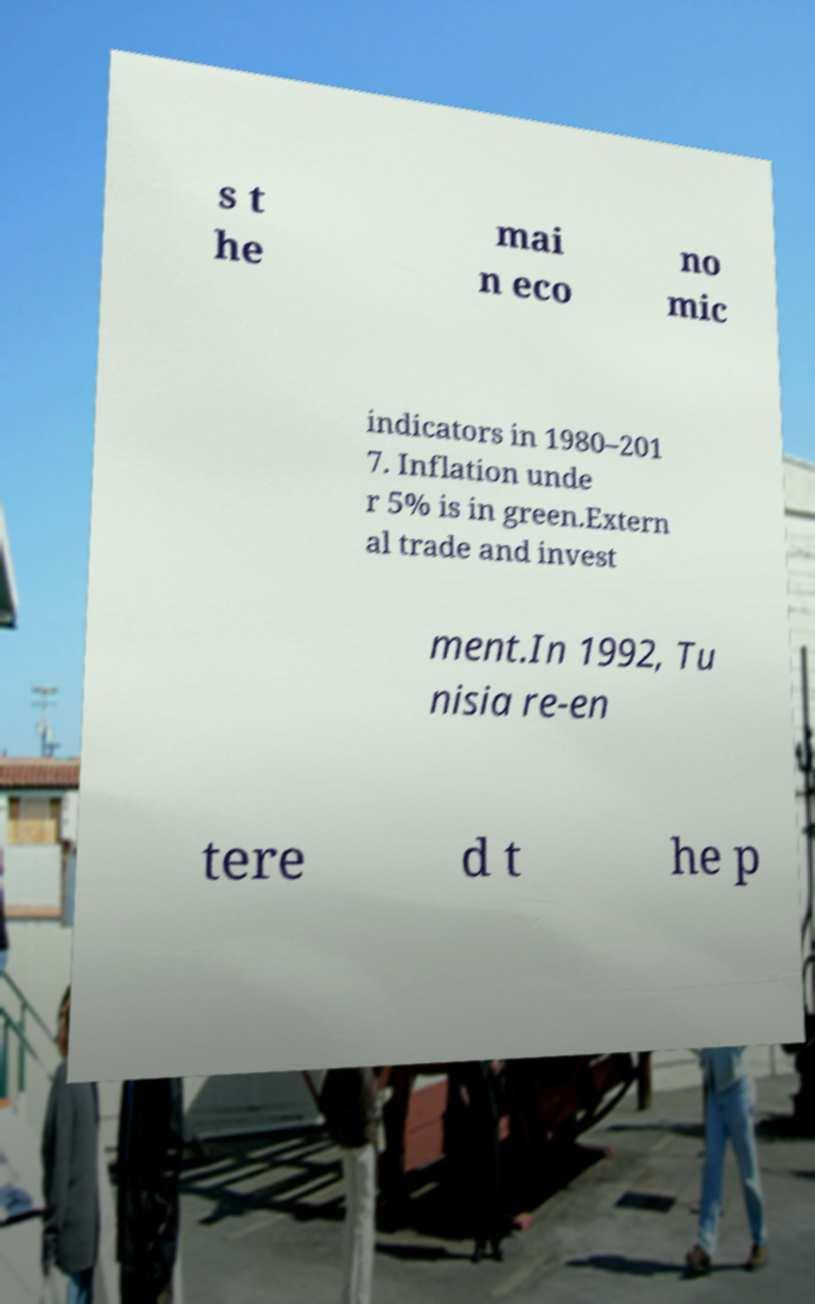Can you accurately transcribe the text from the provided image for me? s t he mai n eco no mic indicators in 1980–201 7. Inflation unde r 5% is in green.Extern al trade and invest ment.In 1992, Tu nisia re-en tere d t he p 